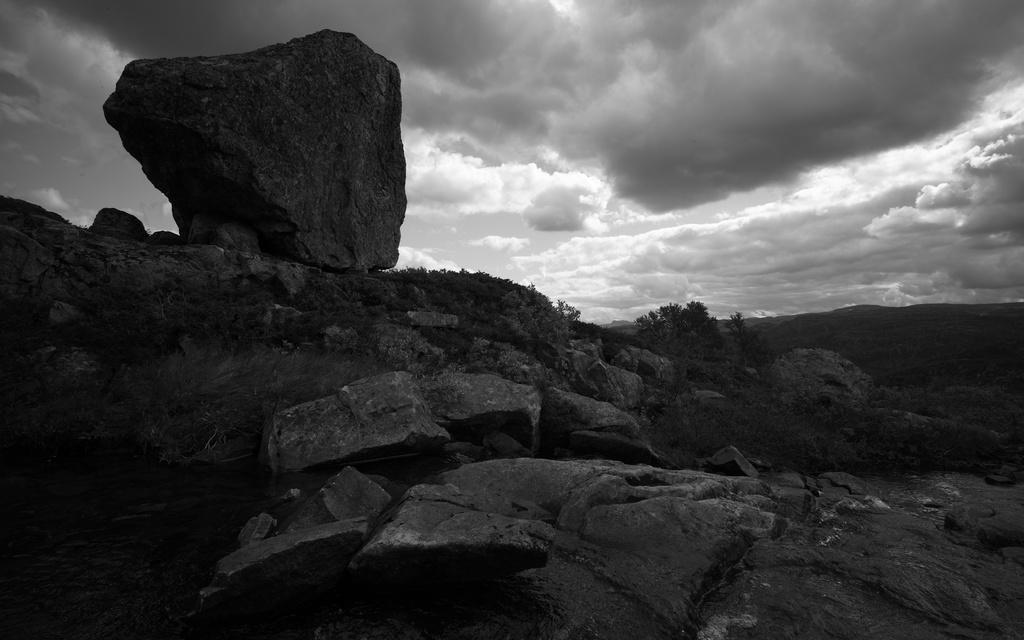In one or two sentences, can you explain what this image depicts? This is a black and white image. In this image we can see rocks, plants, sand and other objects. At the top of the image there is the sky. 